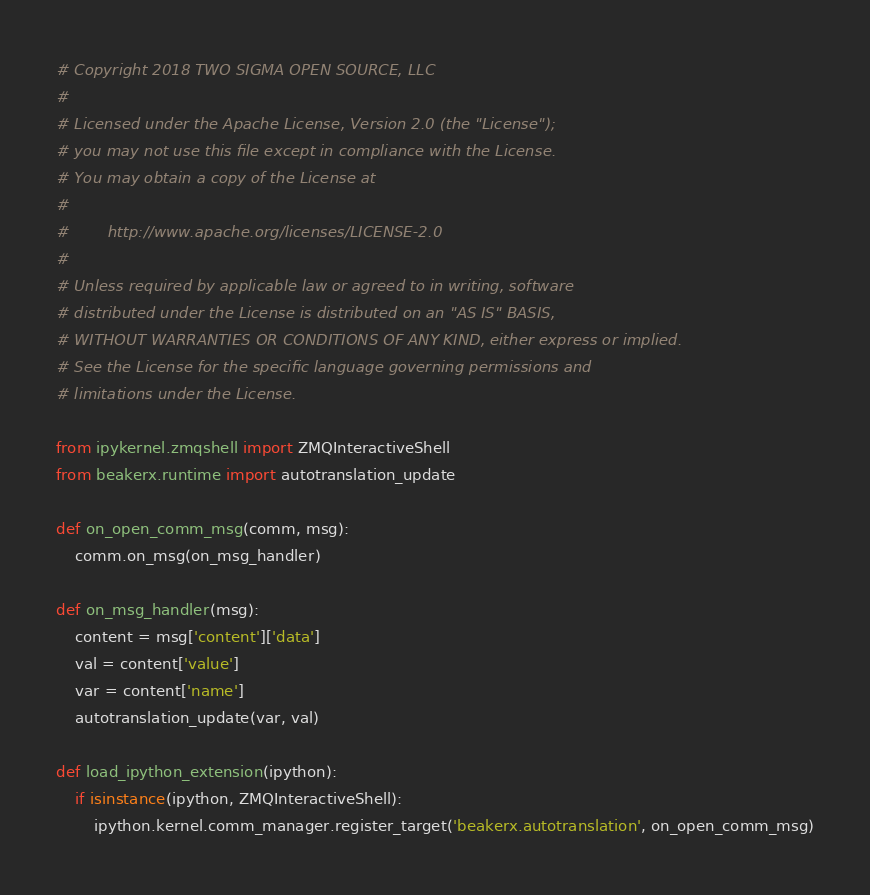<code> <loc_0><loc_0><loc_500><loc_500><_Python_># Copyright 2018 TWO SIGMA OPEN SOURCE, LLC
#
# Licensed under the Apache License, Version 2.0 (the "License");
# you may not use this file except in compliance with the License.
# You may obtain a copy of the License at
#
#        http://www.apache.org/licenses/LICENSE-2.0
#
# Unless required by applicable law or agreed to in writing, software
# distributed under the License is distributed on an "AS IS" BASIS,
# WITHOUT WARRANTIES OR CONDITIONS OF ANY KIND, either express or implied.
# See the License for the specific language governing permissions and
# limitations under the License.

from ipykernel.zmqshell import ZMQInteractiveShell
from beakerx.runtime import autotranslation_update

def on_open_comm_msg(comm, msg):
    comm.on_msg(on_msg_handler)

def on_msg_handler(msg):
    content = msg['content']['data']
    val = content['value']
    var = content['name']
    autotranslation_update(var, val)

def load_ipython_extension(ipython):
    if isinstance(ipython, ZMQInteractiveShell):
        ipython.kernel.comm_manager.register_target('beakerx.autotranslation', on_open_comm_msg)
</code> 